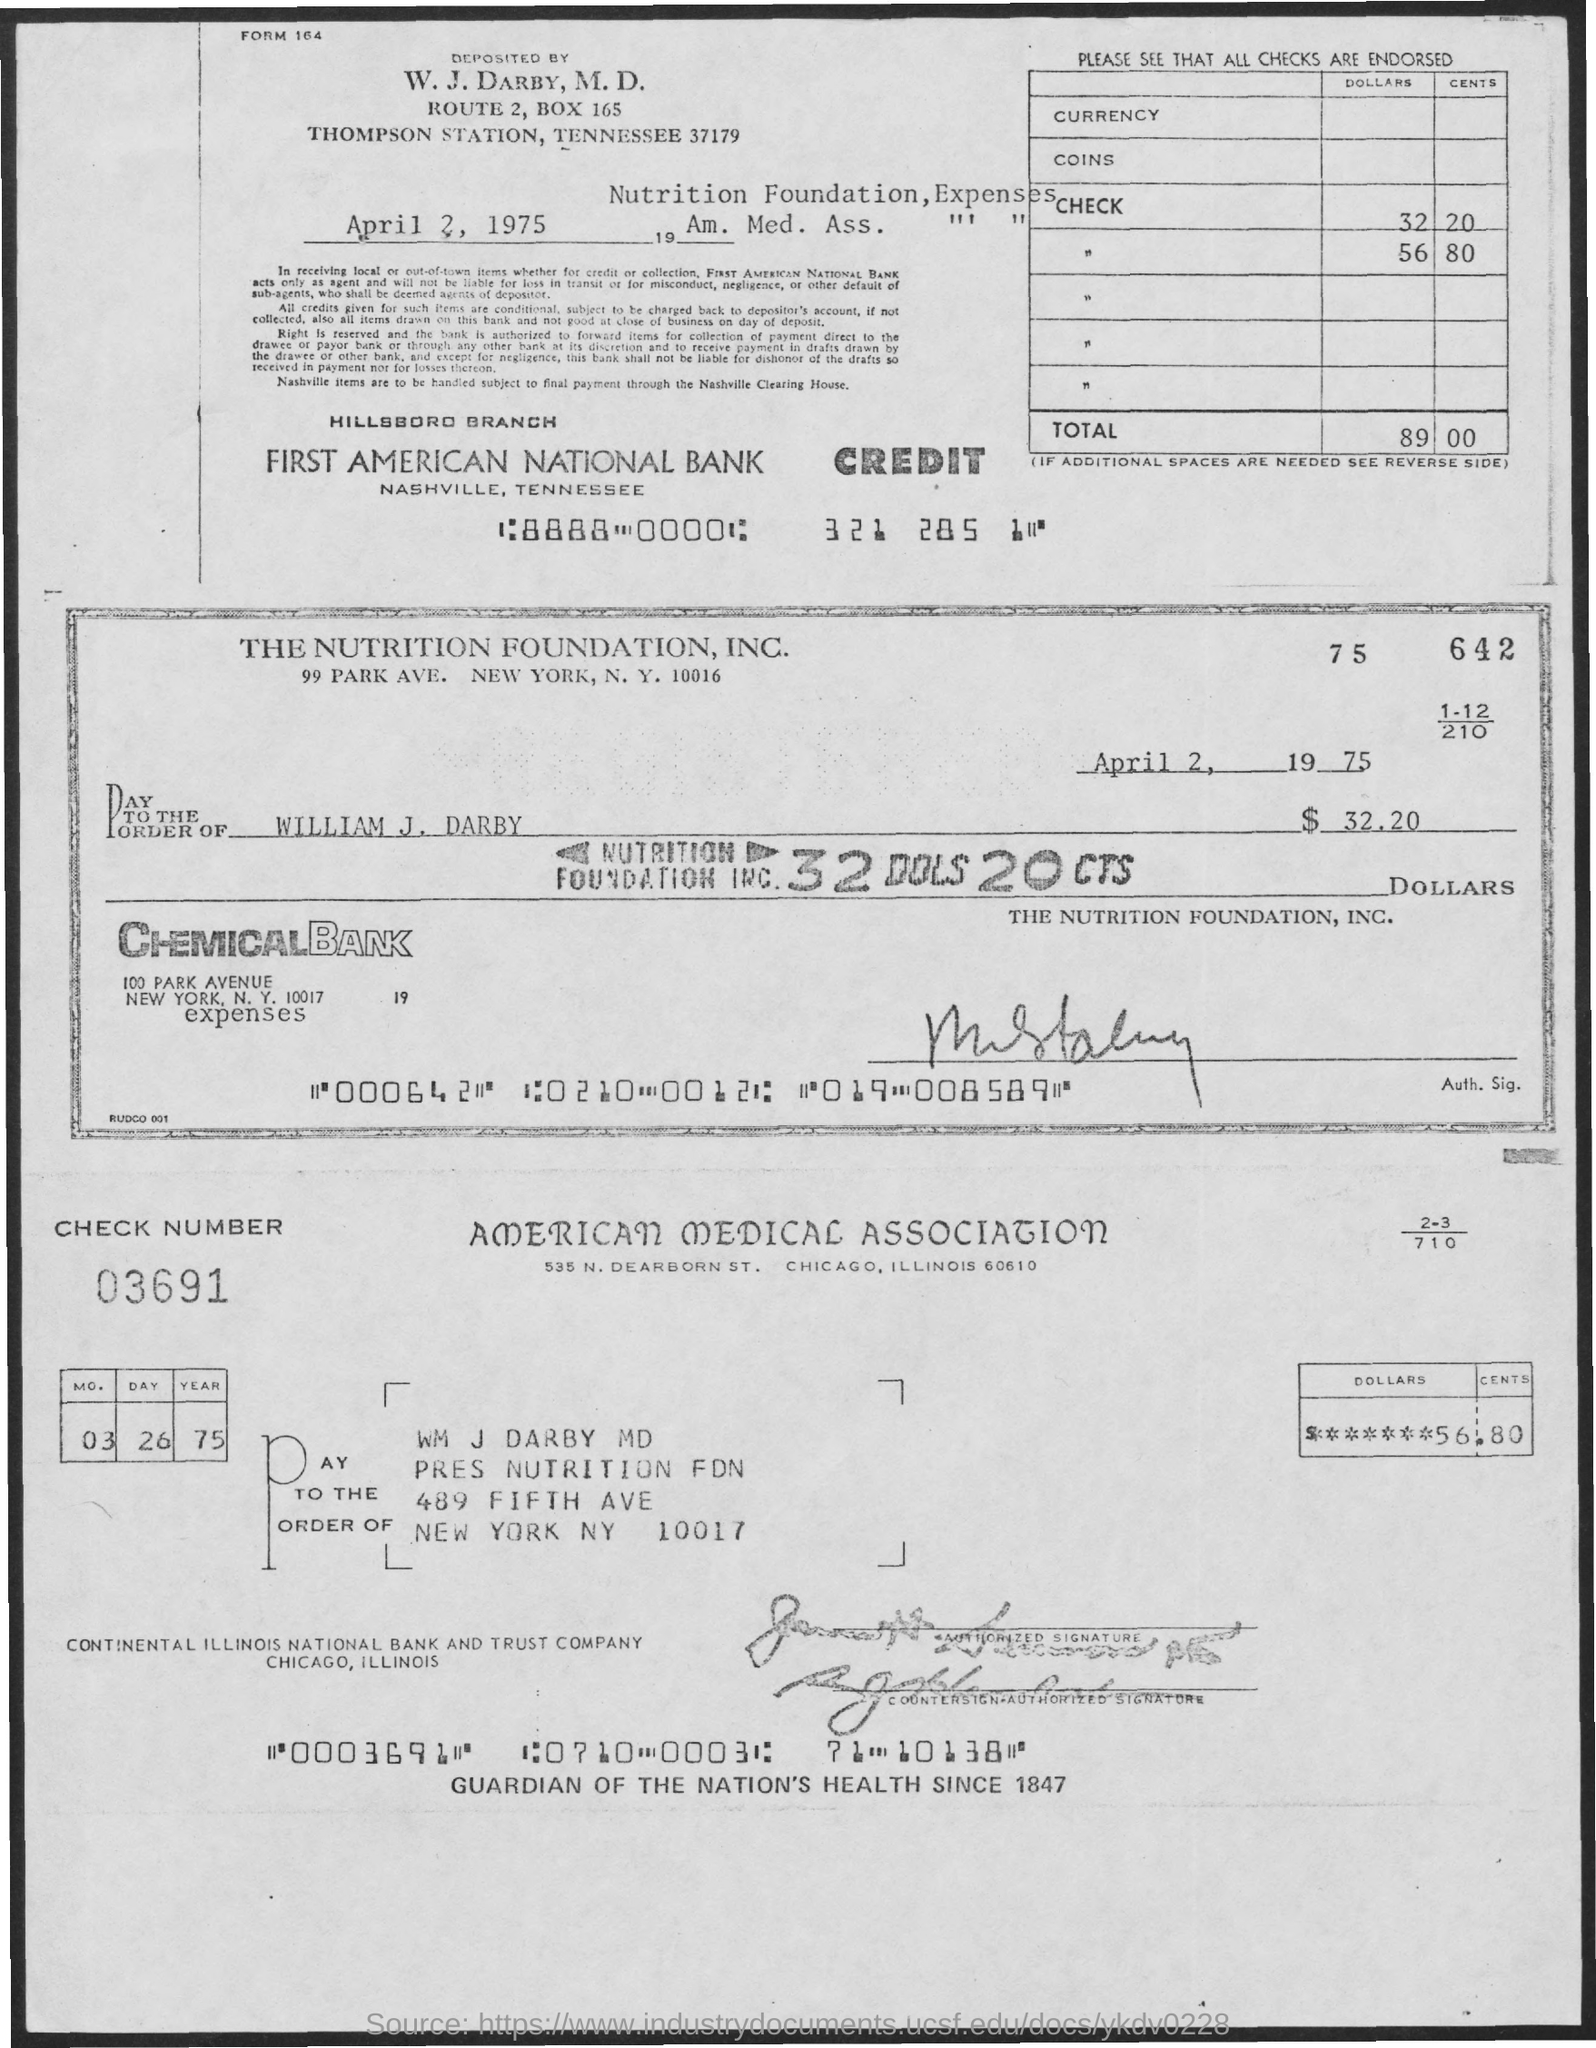Give some essential details in this illustration. The street address of the American Medical Association is 535 N. Dearborn St. The check number is 03691... The Nutrition Foundation, Inc. is located at 99 Park Avenue in New York City. 